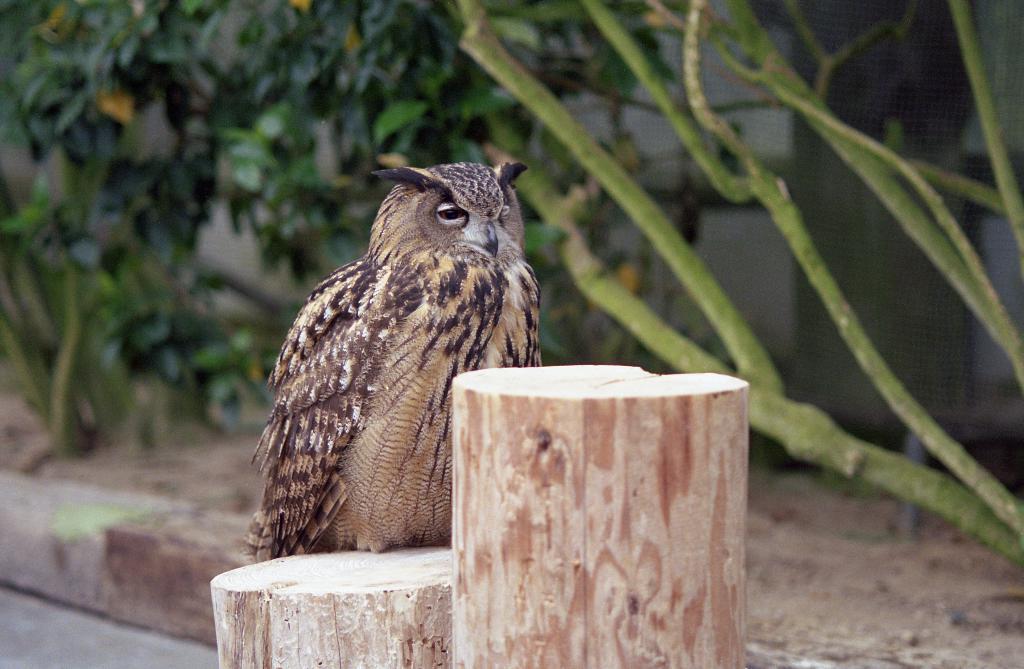Please provide a concise description of this image. In this picture there is a owl on the wooden object. In the background of the image we can see plants and mesh. 